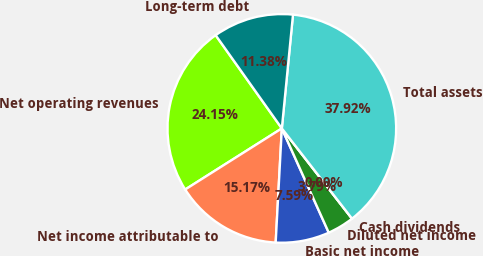Convert chart. <chart><loc_0><loc_0><loc_500><loc_500><pie_chart><fcel>Net operating revenues<fcel>Net income attributable to<fcel>Basic net income<fcel>Diluted net income<fcel>Cash dividends<fcel>Total assets<fcel>Long-term debt<nl><fcel>24.15%<fcel>15.17%<fcel>7.59%<fcel>3.79%<fcel>0.0%<fcel>37.92%<fcel>11.38%<nl></chart> 